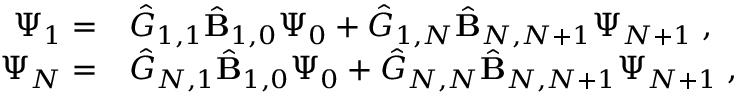Convert formula to latex. <formula><loc_0><loc_0><loc_500><loc_500>\begin{array} { r l } { \Psi _ { 1 } = } & { \hat { G } } _ { 1 , 1 } \hat { B } _ { 1 , 0 } \Psi _ { 0 } + { \hat { G } } _ { 1 , N } \hat { B } _ { N , N + 1 } \Psi _ { N + 1 } \, , } \\ { \Psi _ { N } = } & { \hat { G } } _ { N , 1 } \hat { B } _ { 1 , 0 } \Psi _ { 0 } + { \hat { G } } _ { N , N } \hat { B } _ { N , N + 1 } \Psi _ { N + 1 } \, , } \end{array}</formula> 